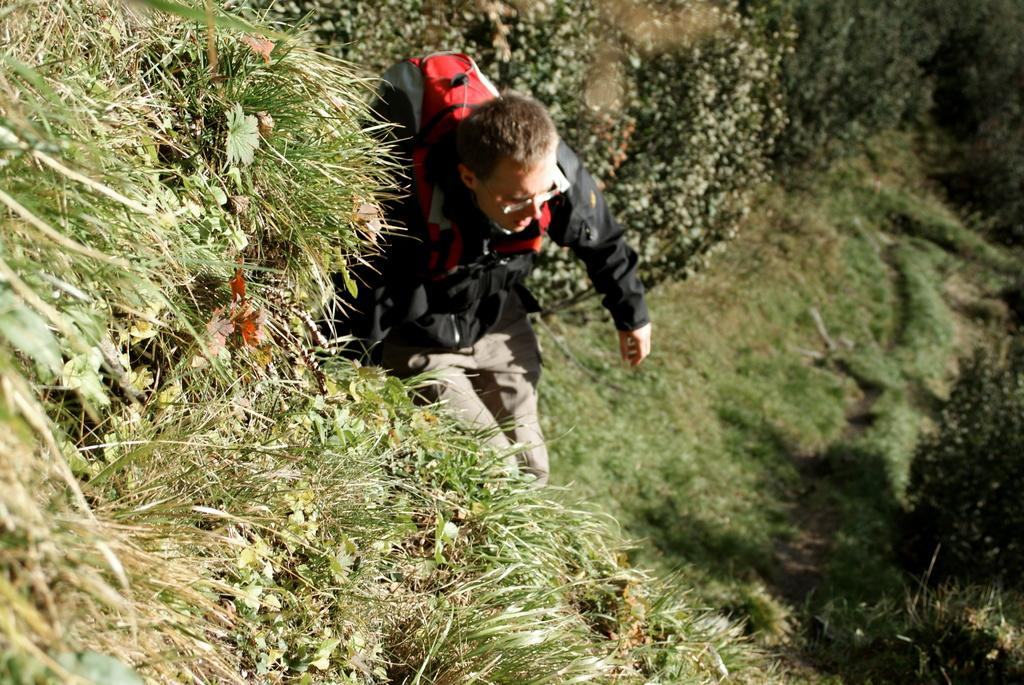What type of vegetation can be seen in the image? There is grass in the image. Can you describe the person in the image? The person is wearing a black shirt and holding a bag. What type of cord is being used to hold the sand in the image? There is no sand or cord present in the image. 